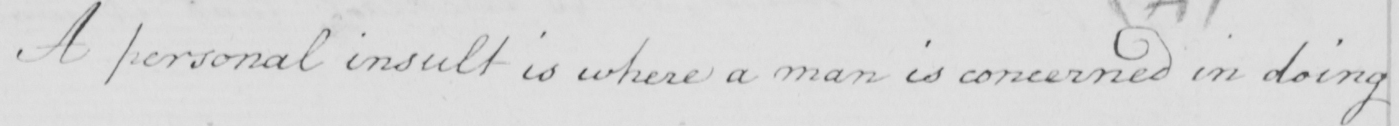What is written in this line of handwriting? A personal insult is where a man is concerned in doing 